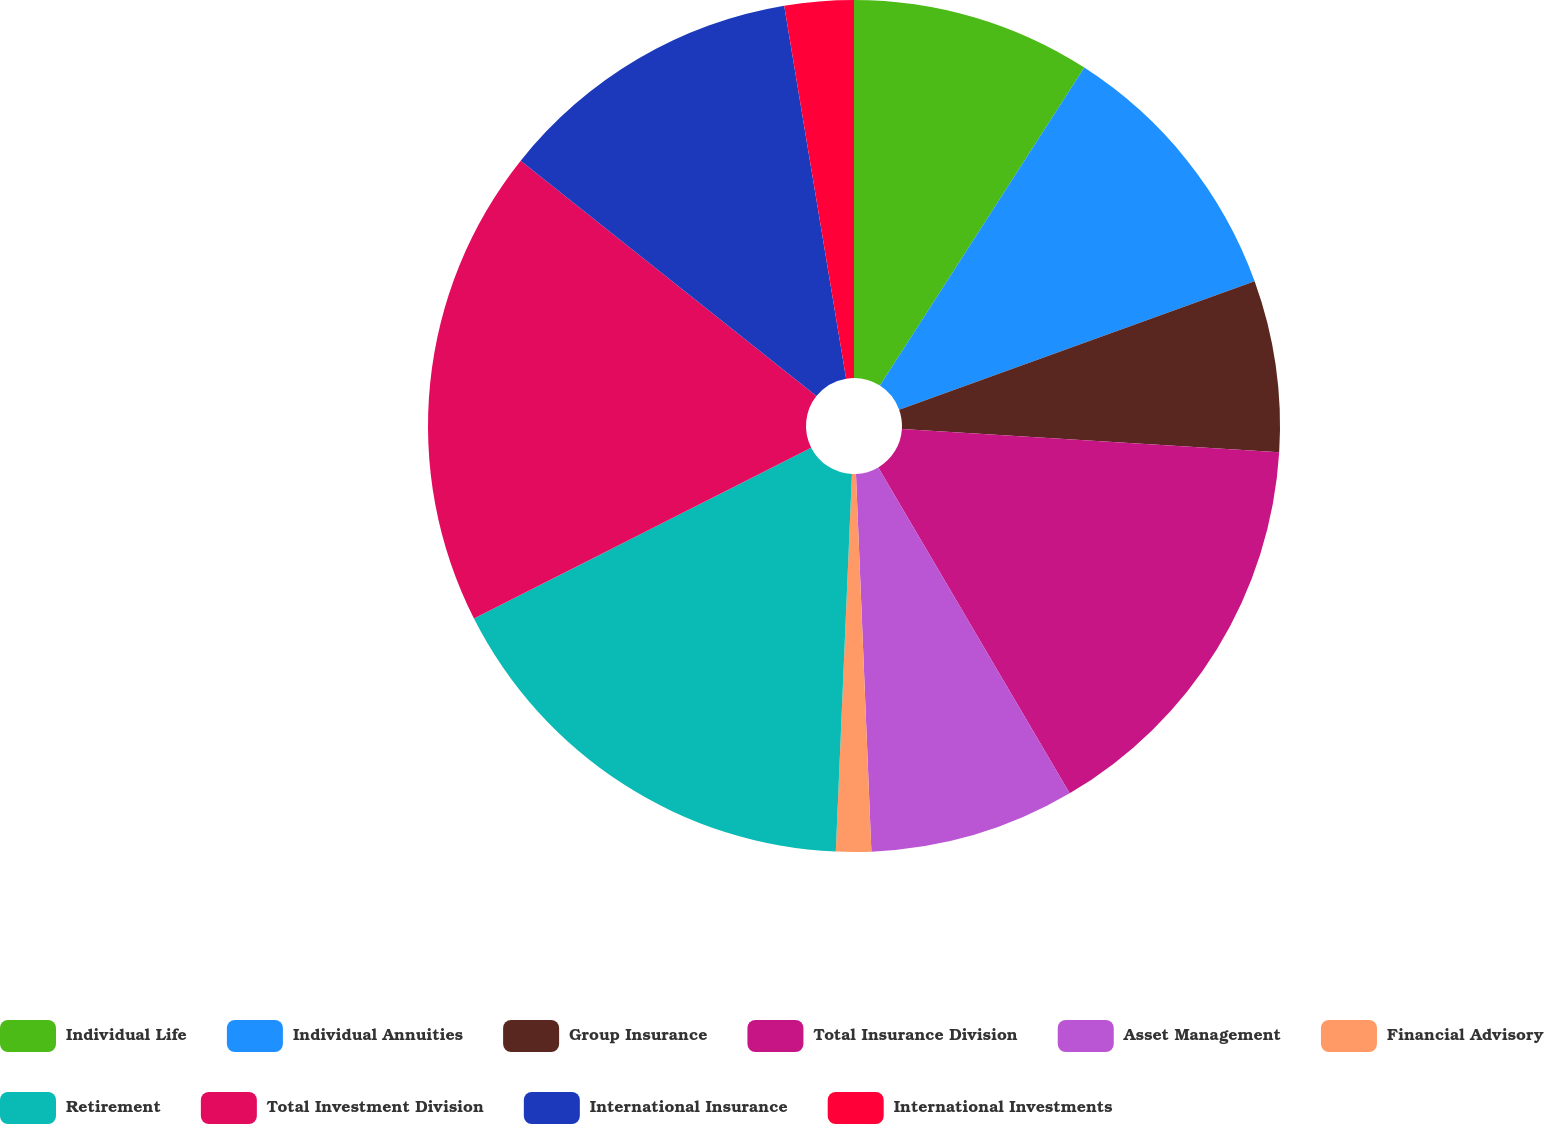Convert chart to OTSL. <chart><loc_0><loc_0><loc_500><loc_500><pie_chart><fcel>Individual Life<fcel>Individual Annuities<fcel>Group Insurance<fcel>Total Insurance Division<fcel>Asset Management<fcel>Financial Advisory<fcel>Retirement<fcel>Total Investment Division<fcel>International Insurance<fcel>International Investments<nl><fcel>9.09%<fcel>10.39%<fcel>6.5%<fcel>15.57%<fcel>7.8%<fcel>1.33%<fcel>16.86%<fcel>18.16%<fcel>11.68%<fcel>2.62%<nl></chart> 